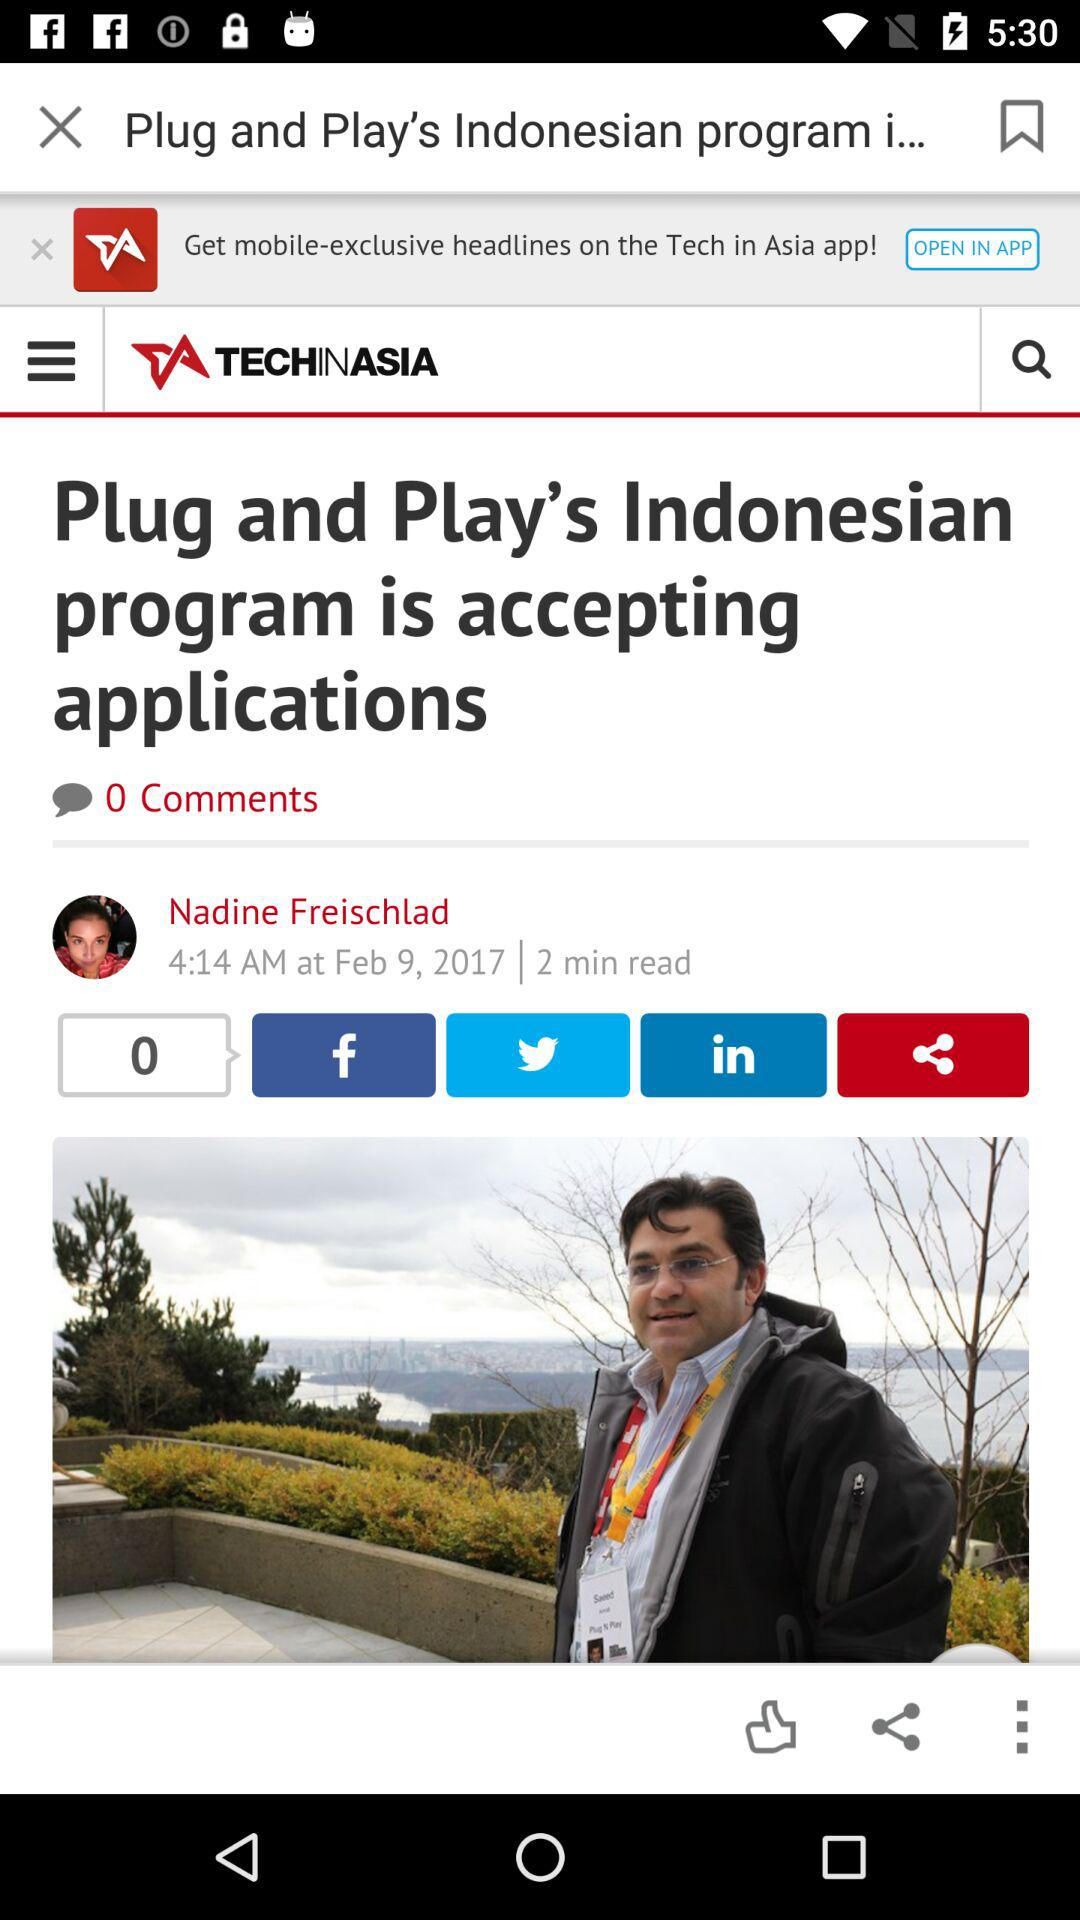How many comments are there? There are 0 comments. 